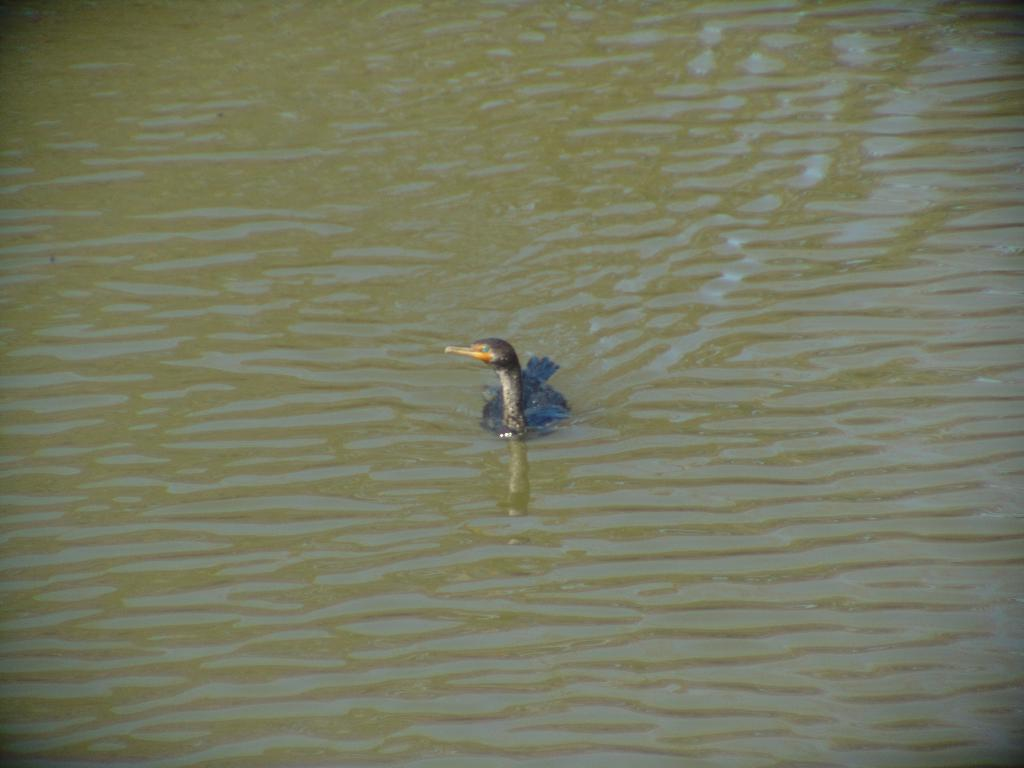What is the main subject of the image? There is a duck in the center of the image. Where is the duck located? The duck is in the water. What type of business is being conducted in the image? There is no business activity depicted in the image; it features a duck in the water. How many ducks are present in the image? There is only one duck present in the image. 